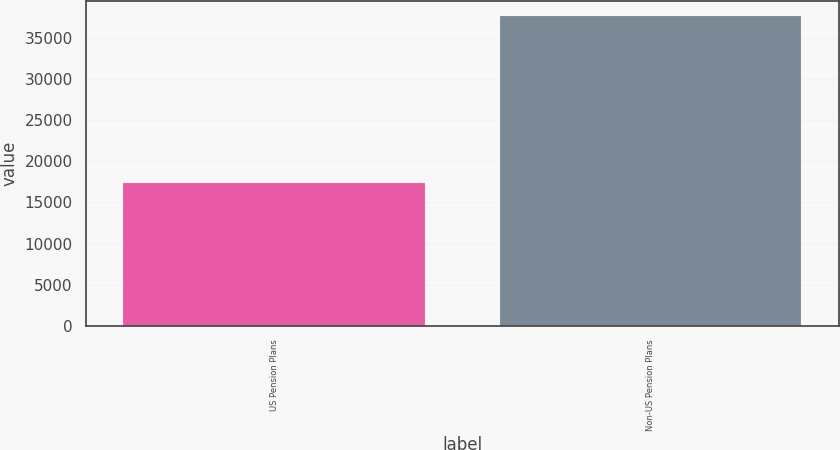Convert chart to OTSL. <chart><loc_0><loc_0><loc_500><loc_500><bar_chart><fcel>US Pension Plans<fcel>Non-US Pension Plans<nl><fcel>17359<fcel>37661<nl></chart> 